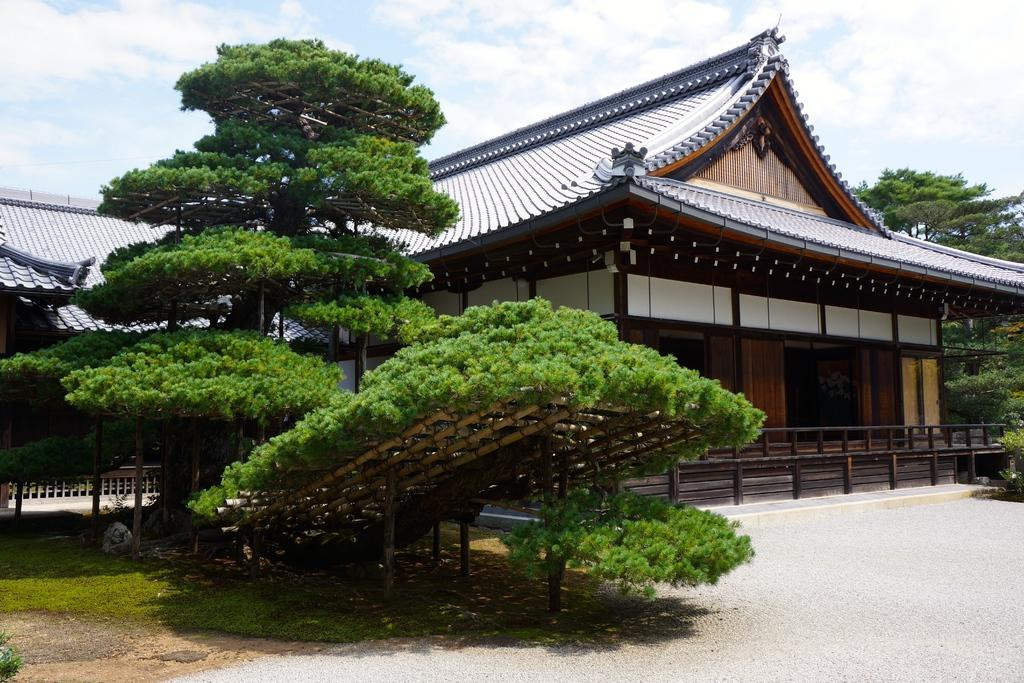What can be seen at the top of the image? The sky with clouds is visible at the top of the image. What type of structure is in the image? There is a house in the image. What is on top of the house? There is a roof top in the image. What type of vegetation is present in the image? Plants and grass are visible in the image. What type of pathway is in the image? There is a road in the image. What type of whip can be seen in the image? There is no whip present in the image. What type of destruction can be seen in the image? There is no destruction present in the image. 